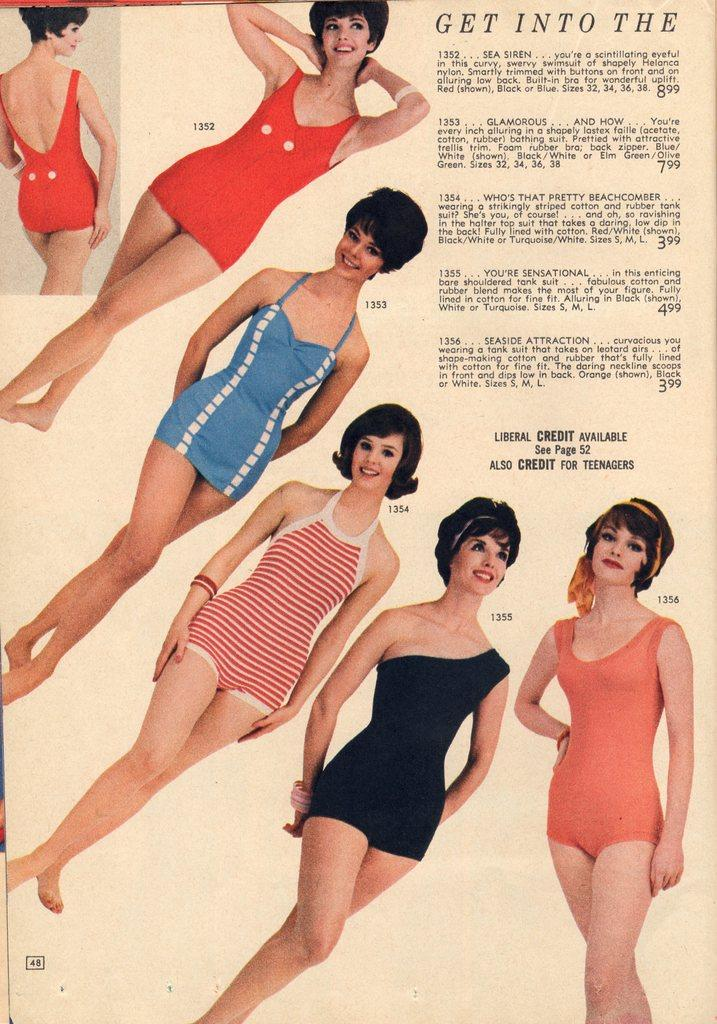What is depicted on the paper in the image? There is a picture of a woman on the paper. What else can be found on the paper besides the picture? There is a paragraph in the top right corner of the paper. How many bushes are surrounding the woman in the image? There are no bushes present in the image; it only features a picture of a woman on a paper. What type of disgust can be seen in the woman's expression in the image? There is no woman present in the image, only a picture of a woman on a paper. 